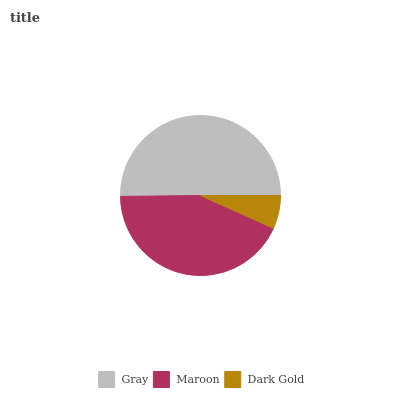Is Dark Gold the minimum?
Answer yes or no. Yes. Is Gray the maximum?
Answer yes or no. Yes. Is Maroon the minimum?
Answer yes or no. No. Is Maroon the maximum?
Answer yes or no. No. Is Gray greater than Maroon?
Answer yes or no. Yes. Is Maroon less than Gray?
Answer yes or no. Yes. Is Maroon greater than Gray?
Answer yes or no. No. Is Gray less than Maroon?
Answer yes or no. No. Is Maroon the high median?
Answer yes or no. Yes. Is Maroon the low median?
Answer yes or no. Yes. Is Dark Gold the high median?
Answer yes or no. No. Is Gray the low median?
Answer yes or no. No. 